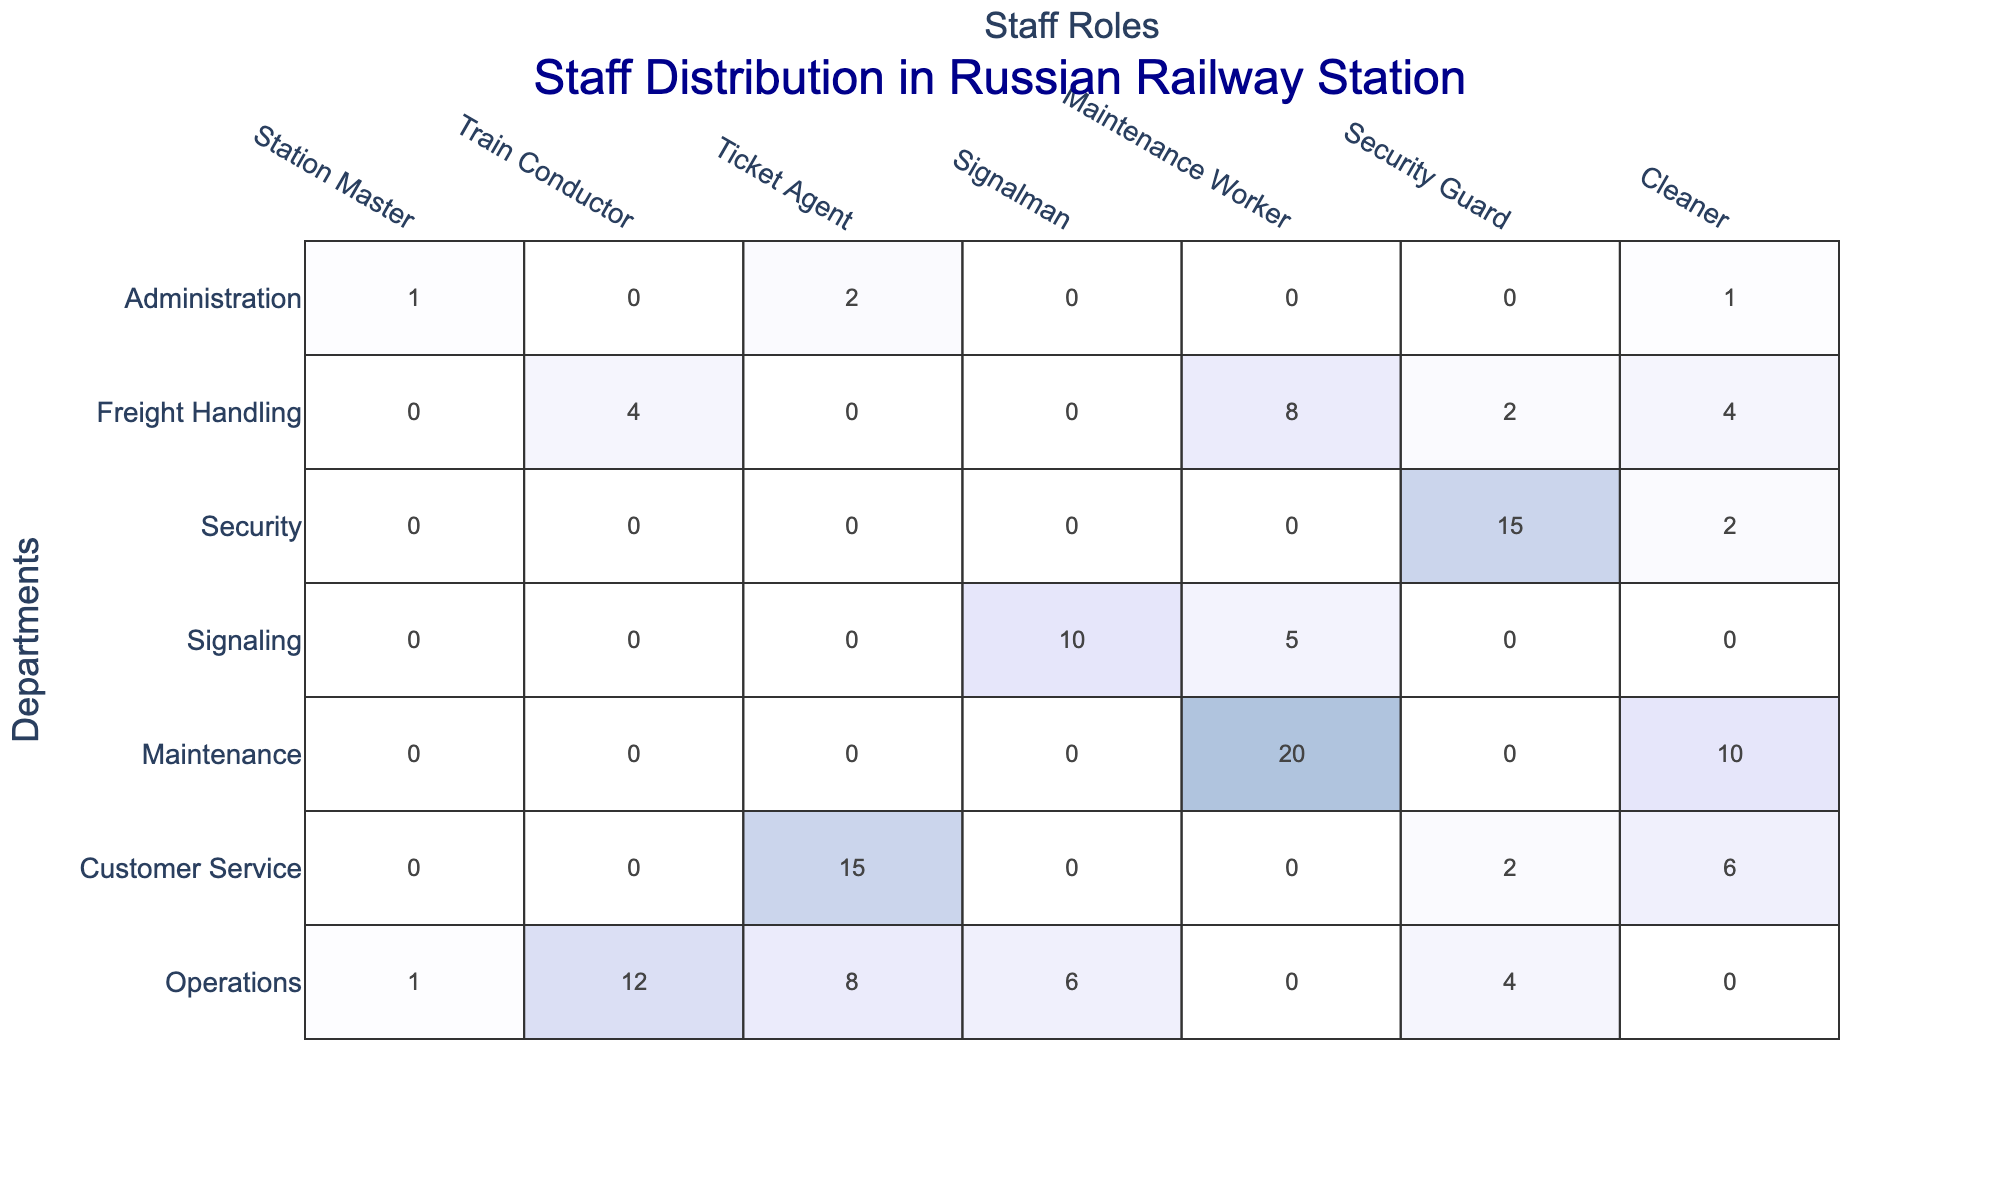What is the total number of Train Conductors across all departments? By adding up the values of Train Conductors from each department: 12 (Operations) + 0 (Customer Service) + 0 (Maintenance) + 0 (Signaling) + 0 (Security) + 4 (Freight Handling) + 0 (Administration) = 16
Answer: 16 Which department has the highest number of Ticket Agents? Looking at the values for Ticket Agents by department, Customer Service has the highest with 15.
Answer: Customer Service How many Security Guards are employed in total across all departments? Adding the Security Guard counts from each department: 4 (Operations) + 2 (Customer Service) + 0 (Maintenance) + 0 (Signaling) + 15 (Security) + 2 (Freight Handling) + 0 (Administration) = 23
Answer: 23 Which department employs the most Maintenance Workers? The Maintenance department has the highest number of Maintenance Workers, with a total of 20.
Answer: Maintenance What is the average number of Cleaners across all departments? The total number of Cleaners is calculated as follows: 0 (Operations) + 6 (Customer Service) + 10 (Maintenance) + 0 (Signaling) + 2 (Security) + 4 (Freight Handling) + 1 (Administration) = 23. There are 7 departments, so the average is 23/7 ≈ 3.29.
Answer: Approximately 3.29 Is there a department that has no Train Conductors at all? By examining the Train Conductor counts, Maintenance, Signaling, Security, and Administration have 0 Train Conductors.
Answer: Yes What is the total number of staff members working in Customer Service? To find this, sum all values for the Customer Service department: 0 (Station Master) + 15 (Ticket Agents) + 0 (Train Conductors) + 0 (Signalman) + 0 (Maintenance Worker) + 2 (Security Guard) + 6 (Cleaner) = 23.
Answer: 23 How does the number of Signalmen in the Signaling department compare with that in the Operations department? The Signaling department has 10 Signalmen, while the Operations department has 6. Therefore, the Signaling department has 4 more.
Answer: Signaling has 4 more Signalmen Are there any departments that do not have Station Masters? Upon reviewing the table, it is clear that Departments without Station Masters include: Customer Service, Maintenance, Signaling, Security, Freight Handling.
Answer: Yes What is the total number of Train Conductors and Ticket Agents in the Operations department? The operations department has 12 Train Conductors and 8 Ticket Agents. Adding these together gives a total of 12 + 8 = 20.
Answer: 20 